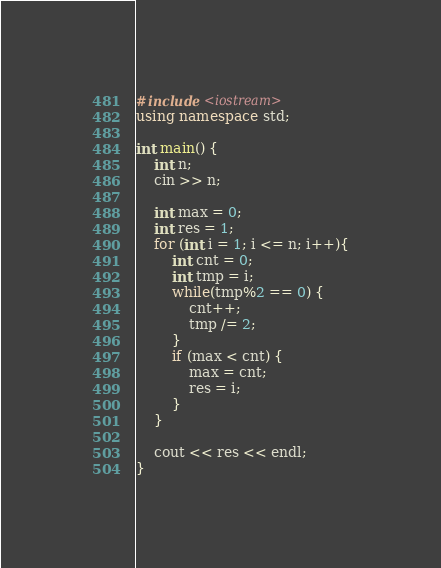Convert code to text. <code><loc_0><loc_0><loc_500><loc_500><_C++_>#include <iostream>
using namespace std;

int main() {
    int n;
    cin >> n;

    int max = 0;
    int res = 1;
    for (int i = 1; i <= n; i++){
        int cnt = 0;
        int tmp = i;
        while(tmp%2 == 0) {
            cnt++;
            tmp /= 2;
        }
        if (max < cnt) {
            max = cnt;
            res = i;
        }
    }

    cout << res << endl;
}</code> 